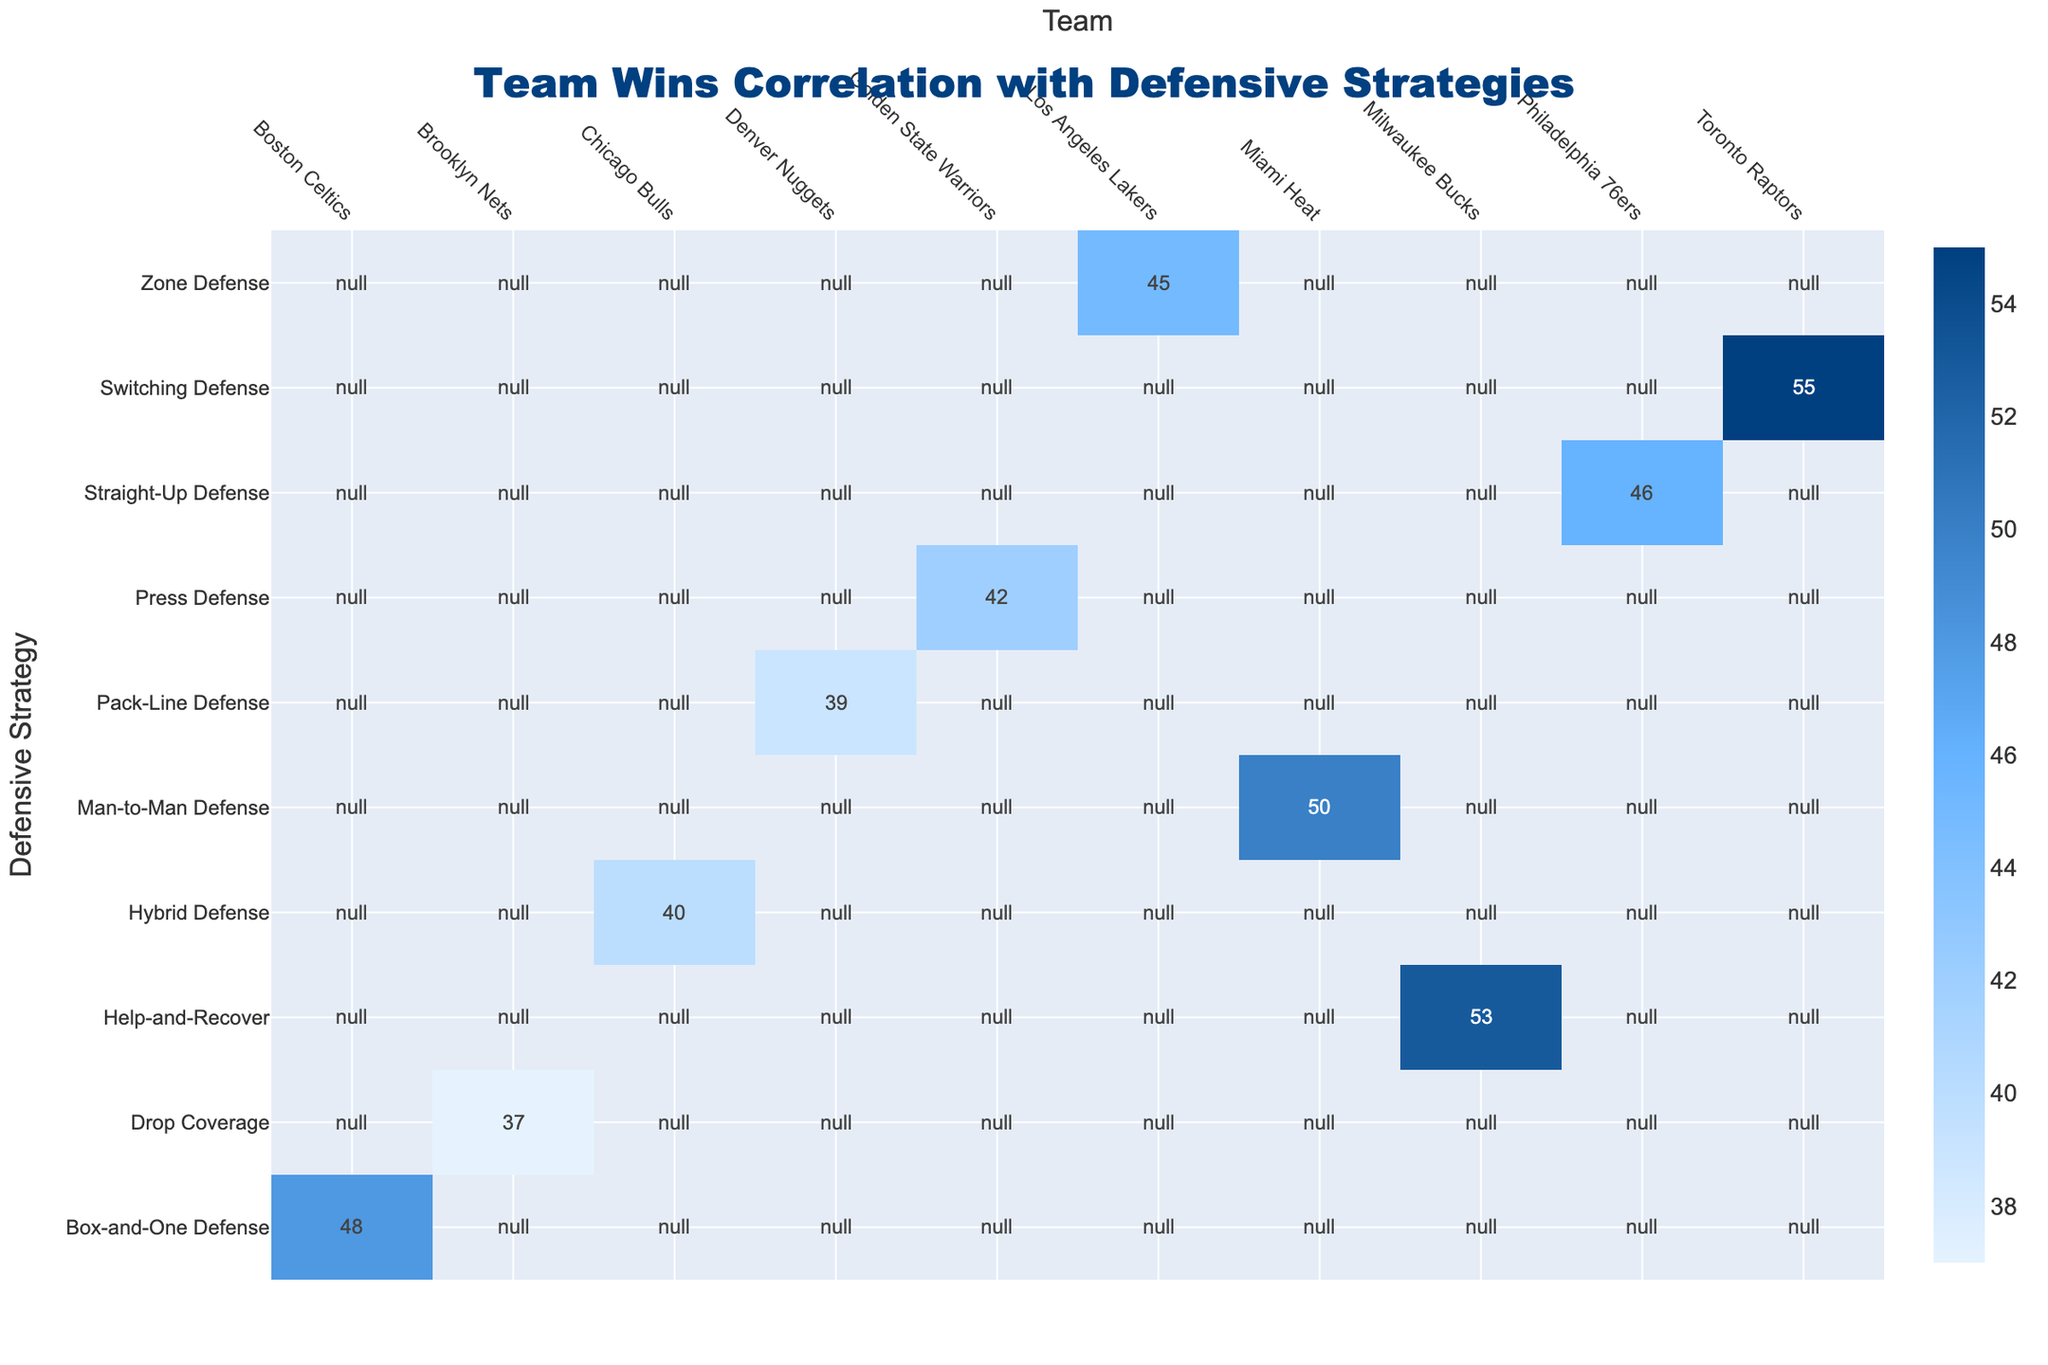What is the total number of wins for the Miami Heat? The table shows the total wins for each team and the Miami Heat has a total of 50 wins listed directly under its row.
Answer: 50 Which team used Zone Defense and how many wins did they have? Referring to the table, the Los Angeles Lakers are associated with Zone Defense, and they have a total of 45 wins indicated in the corresponding row and column.
Answer: Los Angeles Lakers, 45 What is the difference in total wins between the Toronto Raptors and the Brooklyn Nets? The Toronto Raptors have 55 wins while the Brooklyn Nets have 37 wins. The difference is calculated as 55 - 37 = 18.
Answer: 18 Did any team achieve more than 50 wins with a Man-to-Man Defense strategy? Checking the table, the Miami Heat is the only team with Man-to-Man Defense, and they reached a total of 50 wins, hence there are no teams with more than 50 wins using this strategy.
Answer: No Which defensive strategy had the highest total wins, and what was that total? By examining the table, the Toronto Raptors with Switching Defense have the highest total wins at 55, which is directly indicated under their row.
Answer: Switching Defense, 55 What is the average number of wins for teams that used Hybrid Defense and Help-and-Recover? The Chicago Bulls, using Hybrid Defense, have 40 wins. The Milwaukee Bucks using Help-and-Recover have 53 wins. The average is calculated as (40 + 53) / 2 = 46.5.
Answer: 46.5 How many teams had a total of wins less than 45? Looking closely, the teams with fewer than 45 wins are the Chicago Bulls (40), Brooklyn Nets (37), and Denver Nuggets (39). This accounts for 3 teams.
Answer: 3 Which team had a total of wins closest to the average of all teams listed? First, calculate the total wins: 45 + 50 + 42 + 48 + 40 + 37 + 55 + 39 + 53 + 46 = 455 for all 10 teams. The average is 455 / 10 = 45.5. The closest total wins to this average are the Los Angeles Lakers with 45 wins.
Answer: Los Angeles Lakers, 45 